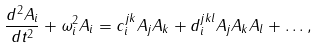<formula> <loc_0><loc_0><loc_500><loc_500>\frac { d ^ { 2 } A _ { i } } { d t ^ { 2 } } + \omega _ { i } ^ { 2 } A _ { i } & = c _ { i } ^ { j k } A _ { j } A _ { k } + d _ { i } ^ { j k l } A _ { j } A _ { k } A _ { l } + \dots ,</formula> 